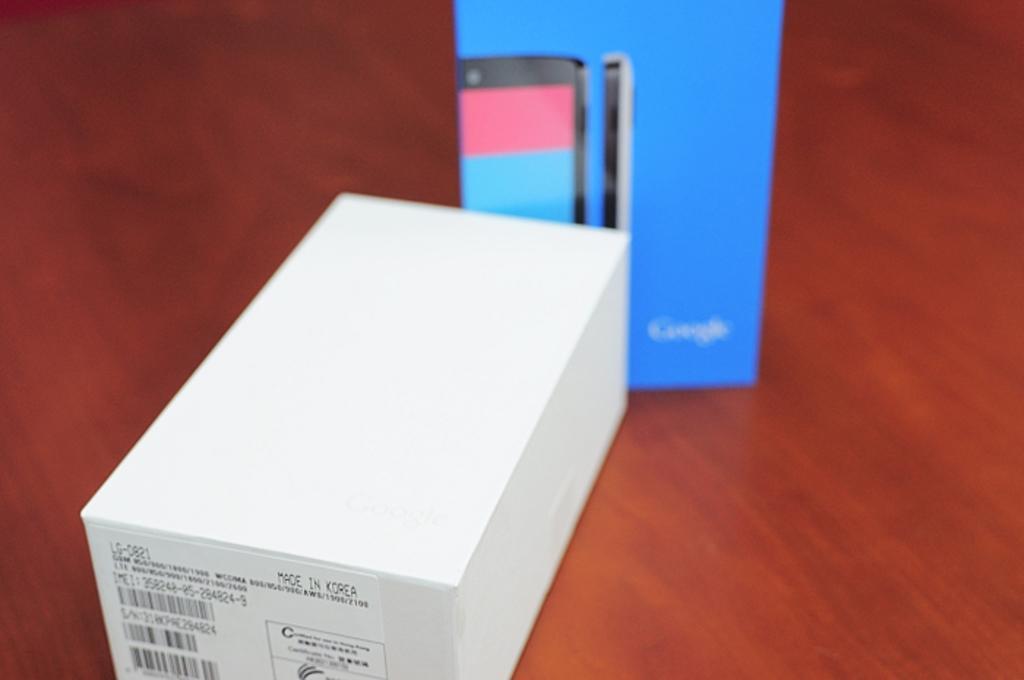<image>
Provide a brief description of the given image. A small white box with a label that states Made in Korea on it 